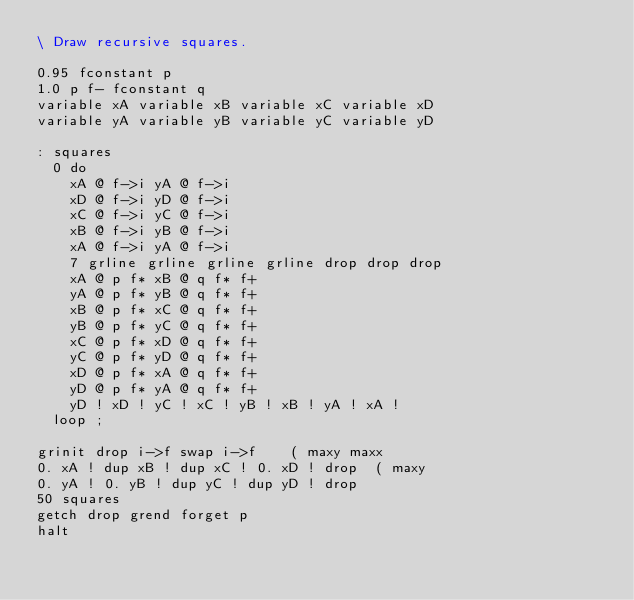<code> <loc_0><loc_0><loc_500><loc_500><_Forth_>\ Draw recursive squares.

0.95 fconstant p
1.0 p f- fconstant q
variable xA variable xB variable xC variable xD
variable yA variable yB variable yC variable yD

: squares
	0 do
		xA @ f->i yA @ f->i
		xD @ f->i yD @ f->i
		xC @ f->i yC @ f->i
		xB @ f->i yB @ f->i
		xA @ f->i yA @ f->i
		7 grline grline grline grline drop drop drop	
		xA @ p f* xB @ q f* f+
		yA @ p f* yB @ q f* f+
		xB @ p f* xC @ q f* f+
		yB @ p f* yC @ q f* f+
		xC @ p f* xD @ q f* f+
		yC @ p f* yD @ q f* f+
		xD @ p f* xA @ q f* f+
		yD @ p f* yA @ q f* f+
		yD ! xD ! yC ! xC ! yB ! xB ! yA ! xA !
	loop ;

grinit drop i->f swap i->f		( maxy maxx
0. xA ! dup xB ! dup xC ! 0. xD ! drop	( maxy
0. yA ! 0. yB ! dup yC ! dup yD ! drop
50 squares
getch drop grend forget p
halt
</code> 